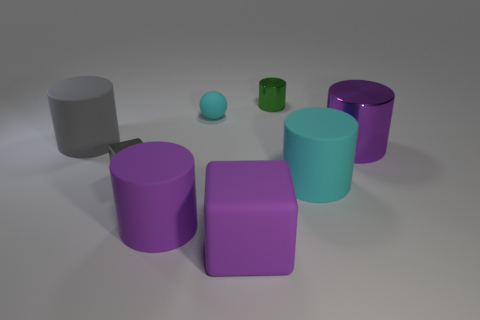Are there any objects in the image that reflect light more than the others? The green and blue cylindrical objects have a higher sheen, indicating a more reflective surface. They reflect light more than the other, more matte objects. 